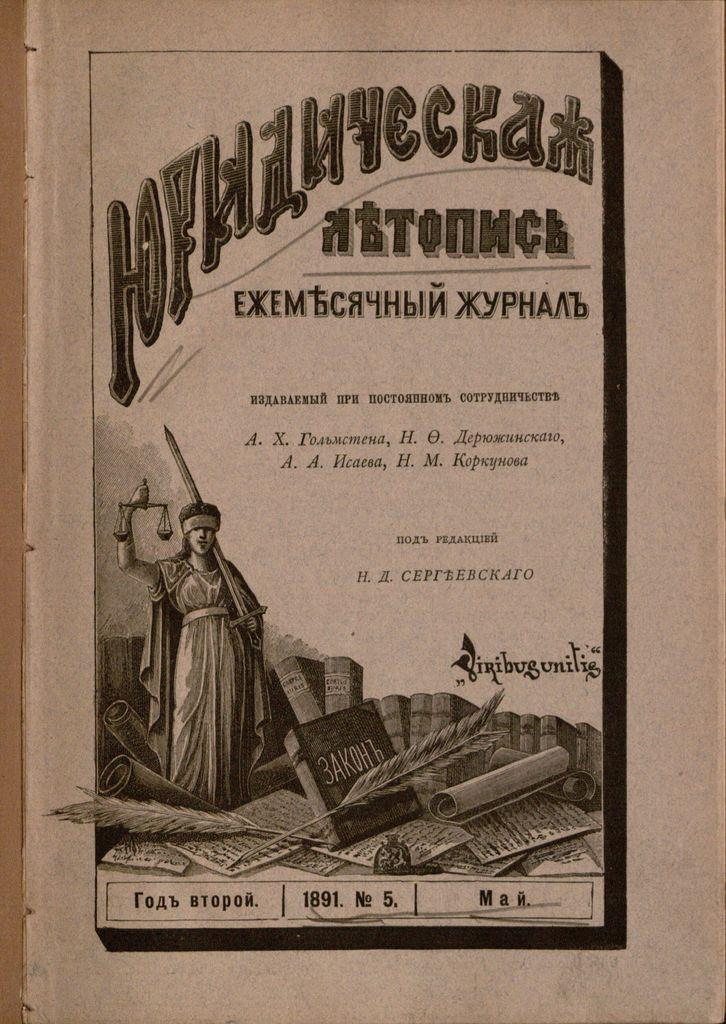What is the main subject of the paper in the image? The paper contains a picture of a sculpture. What else can be found on the paper besides the picture? There is text on the paper. How many dogs are depicted in the sculpture on the paper? There are no dogs depicted in the sculpture on the paper; it is a picture of a sculpture, not a picture of dogs. 